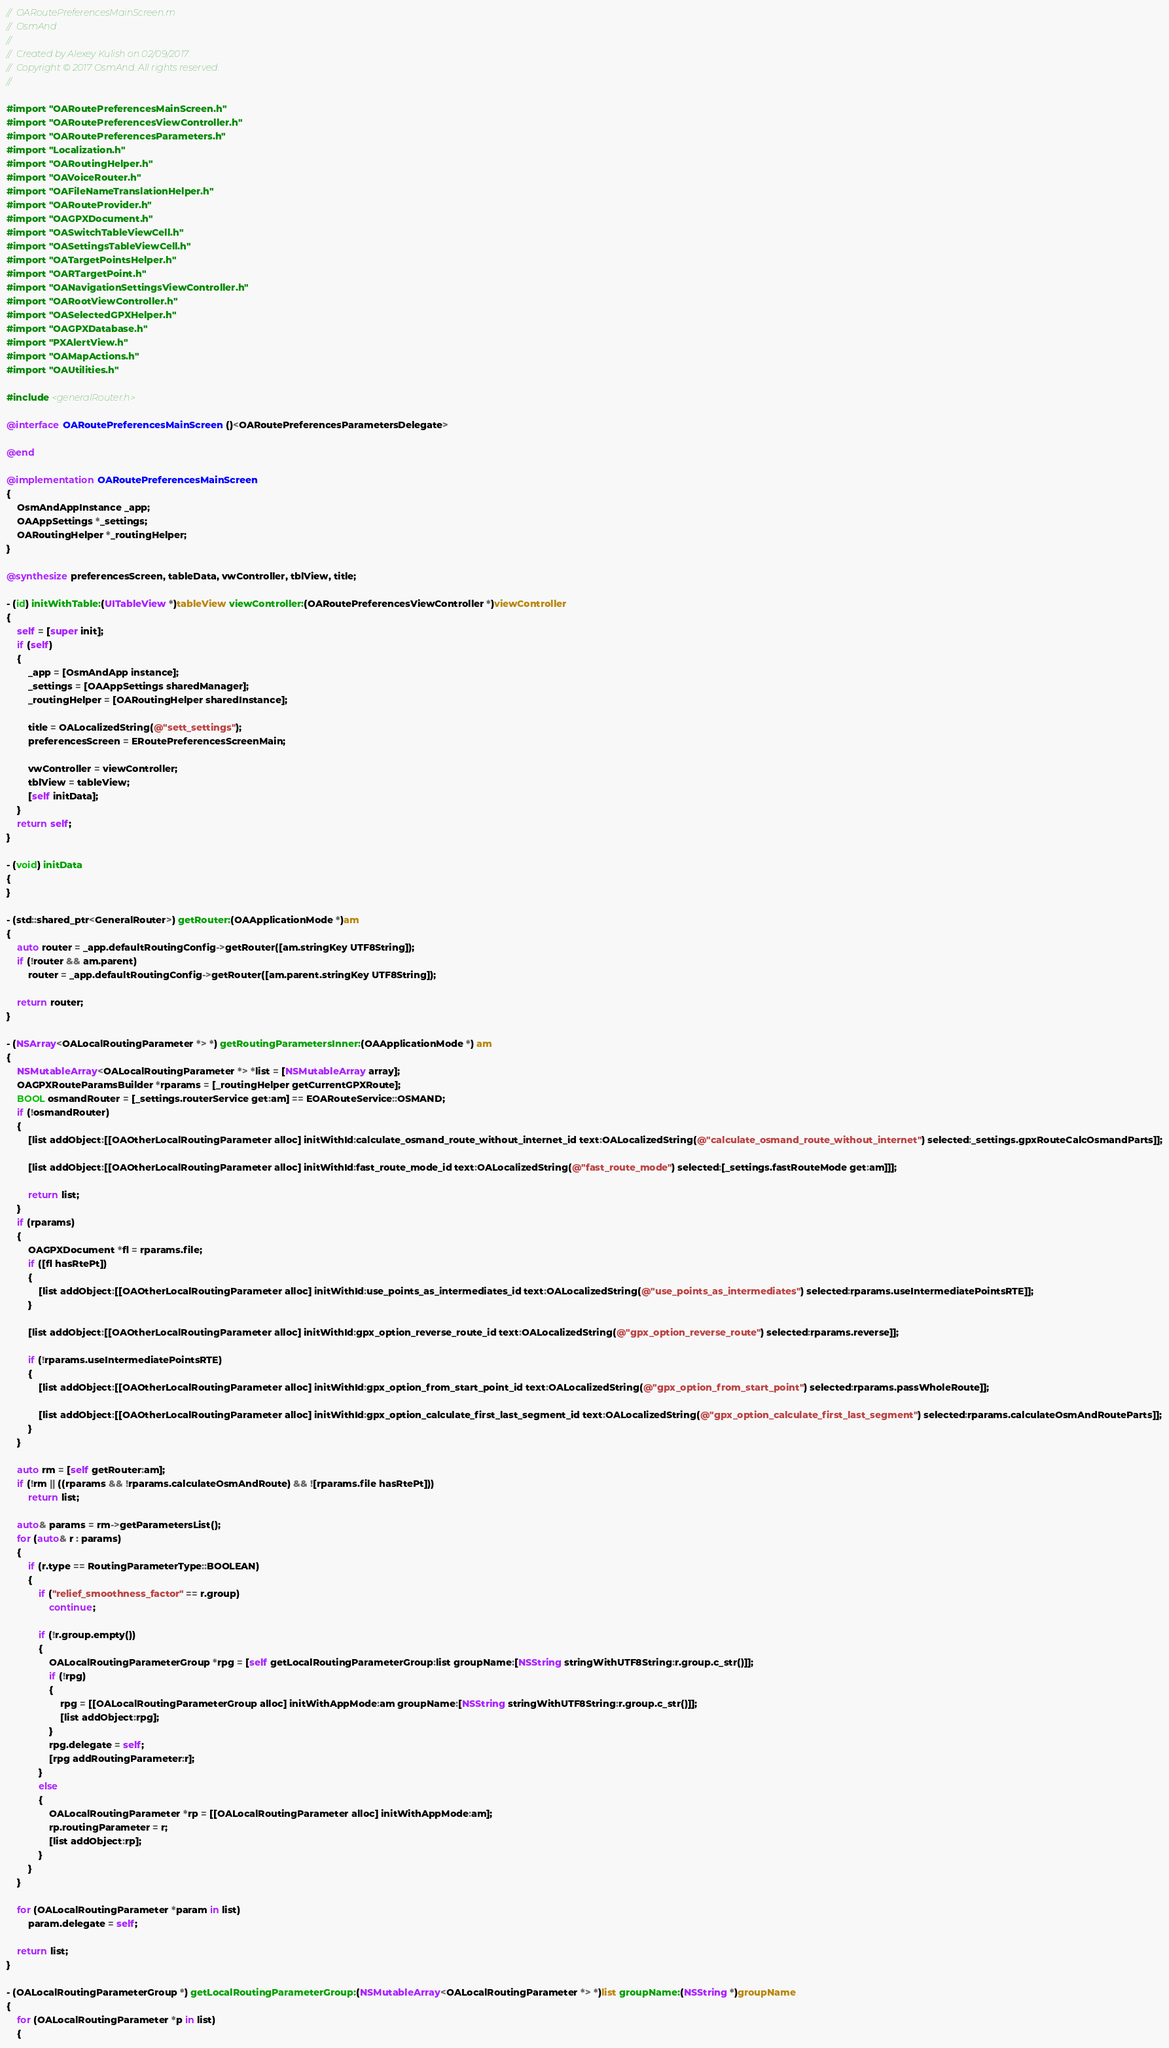<code> <loc_0><loc_0><loc_500><loc_500><_ObjectiveC_>//  OARoutePreferencesMainScreen.m
//  OsmAnd
//
//  Created by Alexey Kulish on 02/09/2017.
//  Copyright © 2017 OsmAnd. All rights reserved.
//

#import "OARoutePreferencesMainScreen.h"
#import "OARoutePreferencesViewController.h"
#import "OARoutePreferencesParameters.h"
#import "Localization.h"
#import "OARoutingHelper.h"
#import "OAVoiceRouter.h"
#import "OAFileNameTranslationHelper.h"
#import "OARouteProvider.h"
#import "OAGPXDocument.h"
#import "OASwitchTableViewCell.h"
#import "OASettingsTableViewCell.h"
#import "OATargetPointsHelper.h"
#import "OARTargetPoint.h"
#import "OANavigationSettingsViewController.h"
#import "OARootViewController.h"
#import "OASelectedGPXHelper.h"
#import "OAGPXDatabase.h"
#import "PXAlertView.h"
#import "OAMapActions.h"
#import "OAUtilities.h"

#include <generalRouter.h>

@interface OARoutePreferencesMainScreen ()<OARoutePreferencesParametersDelegate>

@end

@implementation OARoutePreferencesMainScreen
{
    OsmAndAppInstance _app;
    OAAppSettings *_settings;
    OARoutingHelper *_routingHelper;
}

@synthesize preferencesScreen, tableData, vwController, tblView, title;

- (id) initWithTable:(UITableView *)tableView viewController:(OARoutePreferencesViewController *)viewController
{
    self = [super init];
    if (self)
    {
        _app = [OsmAndApp instance];
        _settings = [OAAppSettings sharedManager];
        _routingHelper = [OARoutingHelper sharedInstance];
        
        title = OALocalizedString(@"sett_settings");
        preferencesScreen = ERoutePreferencesScreenMain;
        
        vwController = viewController;
        tblView = tableView;
        [self initData];
    }
    return self;
}

- (void) initData
{
}

- (std::shared_ptr<GeneralRouter>) getRouter:(OAApplicationMode *)am
{
    auto router = _app.defaultRoutingConfig->getRouter([am.stringKey UTF8String]);
    if (!router && am.parent)
        router = _app.defaultRoutingConfig->getRouter([am.parent.stringKey UTF8String]);
    
    return router;
}

- (NSArray<OALocalRoutingParameter *> *) getRoutingParametersInner:(OAApplicationMode *) am
{
    NSMutableArray<OALocalRoutingParameter *> *list = [NSMutableArray array];
    OAGPXRouteParamsBuilder *rparams = [_routingHelper getCurrentGPXRoute];
    BOOL osmandRouter = [_settings.routerService get:am] == EOARouteService::OSMAND;
    if (!osmandRouter)
    {
        [list addObject:[[OAOtherLocalRoutingParameter alloc] initWithId:calculate_osmand_route_without_internet_id text:OALocalizedString(@"calculate_osmand_route_without_internet") selected:_settings.gpxRouteCalcOsmandParts]];
        
        [list addObject:[[OAOtherLocalRoutingParameter alloc] initWithId:fast_route_mode_id text:OALocalizedString(@"fast_route_mode") selected:[_settings.fastRouteMode get:am]]];
    
        return list;
    }
    if (rparams)
    {
        OAGPXDocument *fl = rparams.file;
        if ([fl hasRtePt])
        {
            [list addObject:[[OAOtherLocalRoutingParameter alloc] initWithId:use_points_as_intermediates_id text:OALocalizedString(@"use_points_as_intermediates") selected:rparams.useIntermediatePointsRTE]];
        }
        
        [list addObject:[[OAOtherLocalRoutingParameter alloc] initWithId:gpx_option_reverse_route_id text:OALocalizedString(@"gpx_option_reverse_route") selected:rparams.reverse]];
        
        if (!rparams.useIntermediatePointsRTE)
        {
            [list addObject:[[OAOtherLocalRoutingParameter alloc] initWithId:gpx_option_from_start_point_id text:OALocalizedString(@"gpx_option_from_start_point") selected:rparams.passWholeRoute]];
            
            [list addObject:[[OAOtherLocalRoutingParameter alloc] initWithId:gpx_option_calculate_first_last_segment_id text:OALocalizedString(@"gpx_option_calculate_first_last_segment") selected:rparams.calculateOsmAndRouteParts]];
        }
    }
    
    auto rm = [self getRouter:am];
    if (!rm || ((rparams && !rparams.calculateOsmAndRoute) && ![rparams.file hasRtePt]))
        return list;
    
    auto& params = rm->getParametersList();
    for (auto& r : params)
    {
        if (r.type == RoutingParameterType::BOOLEAN)
        {
            if ("relief_smoothness_factor" == r.group)
                continue;
            
            if (!r.group.empty())
            {
                OALocalRoutingParameterGroup *rpg = [self getLocalRoutingParameterGroup:list groupName:[NSString stringWithUTF8String:r.group.c_str()]];
                if (!rpg)
                {
                    rpg = [[OALocalRoutingParameterGroup alloc] initWithAppMode:am groupName:[NSString stringWithUTF8String:r.group.c_str()]];
                    [list addObject:rpg];
                }
                rpg.delegate = self;
                [rpg addRoutingParameter:r];
            }
            else
            {
                OALocalRoutingParameter *rp = [[OALocalRoutingParameter alloc] initWithAppMode:am];
                rp.routingParameter = r;
                [list addObject:rp];
            }
        }
    }
    
    for (OALocalRoutingParameter *param in list)
        param.delegate = self;

    return list;
}

- (OALocalRoutingParameterGroup *) getLocalRoutingParameterGroup:(NSMutableArray<OALocalRoutingParameter *> *)list groupName:(NSString *)groupName
{
    for (OALocalRoutingParameter *p in list)
    {</code> 